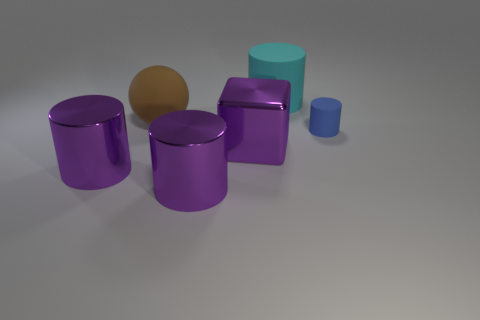Subtract all green balls. Subtract all purple cylinders. How many balls are left? 1 Add 4 purple matte cubes. How many objects exist? 10 Subtract all cylinders. How many objects are left? 2 Subtract all big matte balls. Subtract all brown objects. How many objects are left? 4 Add 4 big purple cylinders. How many big purple cylinders are left? 6 Add 1 big matte balls. How many big matte balls exist? 2 Subtract 0 green balls. How many objects are left? 6 